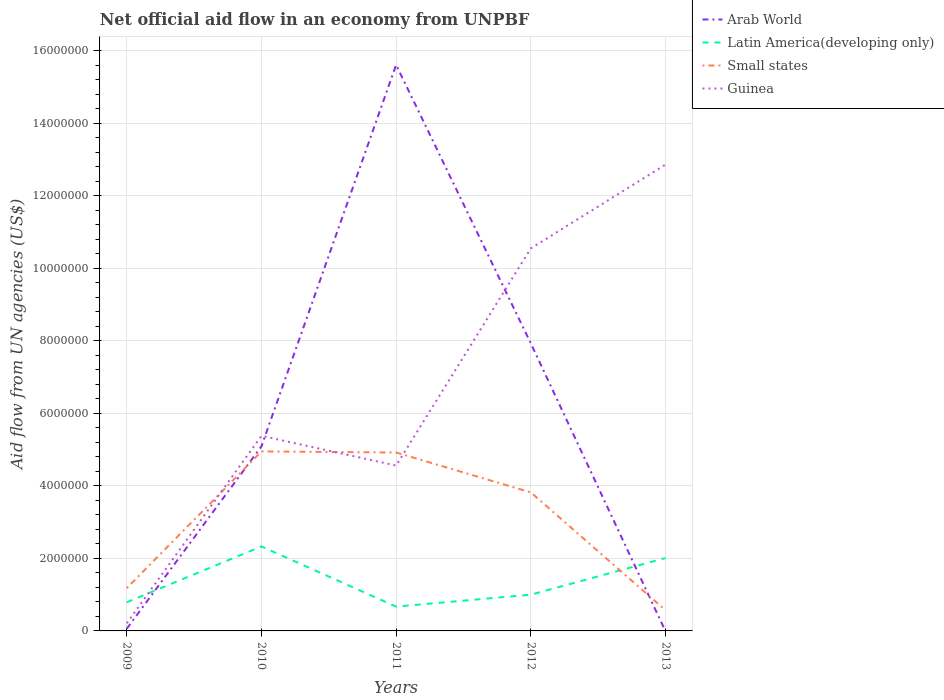Across all years, what is the maximum net official aid flow in Guinea?
Give a very brief answer. 2.10e+05. What is the total net official aid flow in Guinea in the graph?
Keep it short and to the point. -1.26e+07. What is the difference between the highest and the second highest net official aid flow in Small states?
Your answer should be very brief. 4.38e+06. How many lines are there?
Your answer should be compact. 4. How many years are there in the graph?
Your response must be concise. 5. What is the difference between two consecutive major ticks on the Y-axis?
Offer a terse response. 2.00e+06. What is the title of the graph?
Your answer should be compact. Net official aid flow in an economy from UNPBF. Does "Solomon Islands" appear as one of the legend labels in the graph?
Give a very brief answer. No. What is the label or title of the X-axis?
Your response must be concise. Years. What is the label or title of the Y-axis?
Ensure brevity in your answer.  Aid flow from UN agencies (US$). What is the Aid flow from UN agencies (US$) of Latin America(developing only) in 2009?
Your response must be concise. 7.90e+05. What is the Aid flow from UN agencies (US$) in Small states in 2009?
Offer a very short reply. 1.18e+06. What is the Aid flow from UN agencies (US$) of Arab World in 2010?
Your answer should be compact. 5.09e+06. What is the Aid flow from UN agencies (US$) in Latin America(developing only) in 2010?
Make the answer very short. 2.33e+06. What is the Aid flow from UN agencies (US$) in Small states in 2010?
Make the answer very short. 4.95e+06. What is the Aid flow from UN agencies (US$) of Guinea in 2010?
Keep it short and to the point. 5.38e+06. What is the Aid flow from UN agencies (US$) of Arab World in 2011?
Your answer should be very brief. 1.56e+07. What is the Aid flow from UN agencies (US$) of Latin America(developing only) in 2011?
Give a very brief answer. 6.70e+05. What is the Aid flow from UN agencies (US$) in Small states in 2011?
Your answer should be very brief. 4.92e+06. What is the Aid flow from UN agencies (US$) in Guinea in 2011?
Offer a very short reply. 4.56e+06. What is the Aid flow from UN agencies (US$) of Arab World in 2012?
Offer a terse response. 7.93e+06. What is the Aid flow from UN agencies (US$) in Small states in 2012?
Provide a succinct answer. 3.82e+06. What is the Aid flow from UN agencies (US$) in Guinea in 2012?
Your answer should be very brief. 1.06e+07. What is the Aid flow from UN agencies (US$) in Latin America(developing only) in 2013?
Provide a succinct answer. 2.01e+06. What is the Aid flow from UN agencies (US$) in Small states in 2013?
Offer a terse response. 5.70e+05. What is the Aid flow from UN agencies (US$) of Guinea in 2013?
Your answer should be compact. 1.29e+07. Across all years, what is the maximum Aid flow from UN agencies (US$) of Arab World?
Your answer should be very brief. 1.56e+07. Across all years, what is the maximum Aid flow from UN agencies (US$) of Latin America(developing only)?
Provide a succinct answer. 2.33e+06. Across all years, what is the maximum Aid flow from UN agencies (US$) of Small states?
Provide a succinct answer. 4.95e+06. Across all years, what is the maximum Aid flow from UN agencies (US$) of Guinea?
Your answer should be compact. 1.29e+07. Across all years, what is the minimum Aid flow from UN agencies (US$) of Arab World?
Provide a succinct answer. 0. Across all years, what is the minimum Aid flow from UN agencies (US$) of Latin America(developing only)?
Offer a terse response. 6.70e+05. Across all years, what is the minimum Aid flow from UN agencies (US$) in Small states?
Your response must be concise. 5.70e+05. What is the total Aid flow from UN agencies (US$) of Arab World in the graph?
Offer a very short reply. 2.87e+07. What is the total Aid flow from UN agencies (US$) of Latin America(developing only) in the graph?
Ensure brevity in your answer.  6.80e+06. What is the total Aid flow from UN agencies (US$) in Small states in the graph?
Your response must be concise. 1.54e+07. What is the total Aid flow from UN agencies (US$) in Guinea in the graph?
Your response must be concise. 3.36e+07. What is the difference between the Aid flow from UN agencies (US$) in Arab World in 2009 and that in 2010?
Offer a terse response. -5.03e+06. What is the difference between the Aid flow from UN agencies (US$) in Latin America(developing only) in 2009 and that in 2010?
Offer a very short reply. -1.54e+06. What is the difference between the Aid flow from UN agencies (US$) of Small states in 2009 and that in 2010?
Provide a short and direct response. -3.77e+06. What is the difference between the Aid flow from UN agencies (US$) of Guinea in 2009 and that in 2010?
Ensure brevity in your answer.  -5.17e+06. What is the difference between the Aid flow from UN agencies (US$) of Arab World in 2009 and that in 2011?
Give a very brief answer. -1.56e+07. What is the difference between the Aid flow from UN agencies (US$) in Small states in 2009 and that in 2011?
Make the answer very short. -3.74e+06. What is the difference between the Aid flow from UN agencies (US$) in Guinea in 2009 and that in 2011?
Your response must be concise. -4.35e+06. What is the difference between the Aid flow from UN agencies (US$) of Arab World in 2009 and that in 2012?
Make the answer very short. -7.87e+06. What is the difference between the Aid flow from UN agencies (US$) in Latin America(developing only) in 2009 and that in 2012?
Your response must be concise. -2.10e+05. What is the difference between the Aid flow from UN agencies (US$) of Small states in 2009 and that in 2012?
Your answer should be compact. -2.64e+06. What is the difference between the Aid flow from UN agencies (US$) in Guinea in 2009 and that in 2012?
Give a very brief answer. -1.03e+07. What is the difference between the Aid flow from UN agencies (US$) of Latin America(developing only) in 2009 and that in 2013?
Your answer should be compact. -1.22e+06. What is the difference between the Aid flow from UN agencies (US$) of Guinea in 2009 and that in 2013?
Provide a short and direct response. -1.26e+07. What is the difference between the Aid flow from UN agencies (US$) in Arab World in 2010 and that in 2011?
Provide a succinct answer. -1.05e+07. What is the difference between the Aid flow from UN agencies (US$) of Latin America(developing only) in 2010 and that in 2011?
Provide a short and direct response. 1.66e+06. What is the difference between the Aid flow from UN agencies (US$) of Small states in 2010 and that in 2011?
Offer a terse response. 3.00e+04. What is the difference between the Aid flow from UN agencies (US$) in Guinea in 2010 and that in 2011?
Your answer should be very brief. 8.20e+05. What is the difference between the Aid flow from UN agencies (US$) of Arab World in 2010 and that in 2012?
Offer a terse response. -2.84e+06. What is the difference between the Aid flow from UN agencies (US$) in Latin America(developing only) in 2010 and that in 2012?
Your answer should be compact. 1.33e+06. What is the difference between the Aid flow from UN agencies (US$) in Small states in 2010 and that in 2012?
Your answer should be very brief. 1.13e+06. What is the difference between the Aid flow from UN agencies (US$) in Guinea in 2010 and that in 2012?
Your answer should be very brief. -5.17e+06. What is the difference between the Aid flow from UN agencies (US$) in Small states in 2010 and that in 2013?
Your answer should be very brief. 4.38e+06. What is the difference between the Aid flow from UN agencies (US$) of Guinea in 2010 and that in 2013?
Provide a short and direct response. -7.48e+06. What is the difference between the Aid flow from UN agencies (US$) of Arab World in 2011 and that in 2012?
Your response must be concise. 7.68e+06. What is the difference between the Aid flow from UN agencies (US$) in Latin America(developing only) in 2011 and that in 2012?
Give a very brief answer. -3.30e+05. What is the difference between the Aid flow from UN agencies (US$) in Small states in 2011 and that in 2012?
Provide a succinct answer. 1.10e+06. What is the difference between the Aid flow from UN agencies (US$) in Guinea in 2011 and that in 2012?
Offer a terse response. -5.99e+06. What is the difference between the Aid flow from UN agencies (US$) of Latin America(developing only) in 2011 and that in 2013?
Your response must be concise. -1.34e+06. What is the difference between the Aid flow from UN agencies (US$) in Small states in 2011 and that in 2013?
Offer a very short reply. 4.35e+06. What is the difference between the Aid flow from UN agencies (US$) in Guinea in 2011 and that in 2013?
Provide a short and direct response. -8.30e+06. What is the difference between the Aid flow from UN agencies (US$) in Latin America(developing only) in 2012 and that in 2013?
Your answer should be very brief. -1.01e+06. What is the difference between the Aid flow from UN agencies (US$) in Small states in 2012 and that in 2013?
Provide a succinct answer. 3.25e+06. What is the difference between the Aid flow from UN agencies (US$) in Guinea in 2012 and that in 2013?
Your answer should be very brief. -2.31e+06. What is the difference between the Aid flow from UN agencies (US$) in Arab World in 2009 and the Aid flow from UN agencies (US$) in Latin America(developing only) in 2010?
Your response must be concise. -2.27e+06. What is the difference between the Aid flow from UN agencies (US$) in Arab World in 2009 and the Aid flow from UN agencies (US$) in Small states in 2010?
Your answer should be compact. -4.89e+06. What is the difference between the Aid flow from UN agencies (US$) in Arab World in 2009 and the Aid flow from UN agencies (US$) in Guinea in 2010?
Your answer should be compact. -5.32e+06. What is the difference between the Aid flow from UN agencies (US$) of Latin America(developing only) in 2009 and the Aid flow from UN agencies (US$) of Small states in 2010?
Your response must be concise. -4.16e+06. What is the difference between the Aid flow from UN agencies (US$) in Latin America(developing only) in 2009 and the Aid flow from UN agencies (US$) in Guinea in 2010?
Your answer should be very brief. -4.59e+06. What is the difference between the Aid flow from UN agencies (US$) in Small states in 2009 and the Aid flow from UN agencies (US$) in Guinea in 2010?
Your response must be concise. -4.20e+06. What is the difference between the Aid flow from UN agencies (US$) in Arab World in 2009 and the Aid flow from UN agencies (US$) in Latin America(developing only) in 2011?
Ensure brevity in your answer.  -6.10e+05. What is the difference between the Aid flow from UN agencies (US$) of Arab World in 2009 and the Aid flow from UN agencies (US$) of Small states in 2011?
Provide a succinct answer. -4.86e+06. What is the difference between the Aid flow from UN agencies (US$) of Arab World in 2009 and the Aid flow from UN agencies (US$) of Guinea in 2011?
Provide a short and direct response. -4.50e+06. What is the difference between the Aid flow from UN agencies (US$) of Latin America(developing only) in 2009 and the Aid flow from UN agencies (US$) of Small states in 2011?
Your answer should be compact. -4.13e+06. What is the difference between the Aid flow from UN agencies (US$) of Latin America(developing only) in 2009 and the Aid flow from UN agencies (US$) of Guinea in 2011?
Give a very brief answer. -3.77e+06. What is the difference between the Aid flow from UN agencies (US$) of Small states in 2009 and the Aid flow from UN agencies (US$) of Guinea in 2011?
Your answer should be very brief. -3.38e+06. What is the difference between the Aid flow from UN agencies (US$) of Arab World in 2009 and the Aid flow from UN agencies (US$) of Latin America(developing only) in 2012?
Your answer should be compact. -9.40e+05. What is the difference between the Aid flow from UN agencies (US$) in Arab World in 2009 and the Aid flow from UN agencies (US$) in Small states in 2012?
Provide a succinct answer. -3.76e+06. What is the difference between the Aid flow from UN agencies (US$) in Arab World in 2009 and the Aid flow from UN agencies (US$) in Guinea in 2012?
Give a very brief answer. -1.05e+07. What is the difference between the Aid flow from UN agencies (US$) of Latin America(developing only) in 2009 and the Aid flow from UN agencies (US$) of Small states in 2012?
Make the answer very short. -3.03e+06. What is the difference between the Aid flow from UN agencies (US$) of Latin America(developing only) in 2009 and the Aid flow from UN agencies (US$) of Guinea in 2012?
Make the answer very short. -9.76e+06. What is the difference between the Aid flow from UN agencies (US$) in Small states in 2009 and the Aid flow from UN agencies (US$) in Guinea in 2012?
Offer a terse response. -9.37e+06. What is the difference between the Aid flow from UN agencies (US$) in Arab World in 2009 and the Aid flow from UN agencies (US$) in Latin America(developing only) in 2013?
Provide a short and direct response. -1.95e+06. What is the difference between the Aid flow from UN agencies (US$) in Arab World in 2009 and the Aid flow from UN agencies (US$) in Small states in 2013?
Provide a short and direct response. -5.10e+05. What is the difference between the Aid flow from UN agencies (US$) in Arab World in 2009 and the Aid flow from UN agencies (US$) in Guinea in 2013?
Keep it short and to the point. -1.28e+07. What is the difference between the Aid flow from UN agencies (US$) of Latin America(developing only) in 2009 and the Aid flow from UN agencies (US$) of Guinea in 2013?
Provide a succinct answer. -1.21e+07. What is the difference between the Aid flow from UN agencies (US$) of Small states in 2009 and the Aid flow from UN agencies (US$) of Guinea in 2013?
Give a very brief answer. -1.17e+07. What is the difference between the Aid flow from UN agencies (US$) in Arab World in 2010 and the Aid flow from UN agencies (US$) in Latin America(developing only) in 2011?
Make the answer very short. 4.42e+06. What is the difference between the Aid flow from UN agencies (US$) of Arab World in 2010 and the Aid flow from UN agencies (US$) of Guinea in 2011?
Ensure brevity in your answer.  5.30e+05. What is the difference between the Aid flow from UN agencies (US$) in Latin America(developing only) in 2010 and the Aid flow from UN agencies (US$) in Small states in 2011?
Provide a succinct answer. -2.59e+06. What is the difference between the Aid flow from UN agencies (US$) of Latin America(developing only) in 2010 and the Aid flow from UN agencies (US$) of Guinea in 2011?
Provide a short and direct response. -2.23e+06. What is the difference between the Aid flow from UN agencies (US$) in Small states in 2010 and the Aid flow from UN agencies (US$) in Guinea in 2011?
Offer a terse response. 3.90e+05. What is the difference between the Aid flow from UN agencies (US$) of Arab World in 2010 and the Aid flow from UN agencies (US$) of Latin America(developing only) in 2012?
Give a very brief answer. 4.09e+06. What is the difference between the Aid flow from UN agencies (US$) in Arab World in 2010 and the Aid flow from UN agencies (US$) in Small states in 2012?
Your answer should be very brief. 1.27e+06. What is the difference between the Aid flow from UN agencies (US$) of Arab World in 2010 and the Aid flow from UN agencies (US$) of Guinea in 2012?
Provide a short and direct response. -5.46e+06. What is the difference between the Aid flow from UN agencies (US$) of Latin America(developing only) in 2010 and the Aid flow from UN agencies (US$) of Small states in 2012?
Give a very brief answer. -1.49e+06. What is the difference between the Aid flow from UN agencies (US$) of Latin America(developing only) in 2010 and the Aid flow from UN agencies (US$) of Guinea in 2012?
Offer a very short reply. -8.22e+06. What is the difference between the Aid flow from UN agencies (US$) of Small states in 2010 and the Aid flow from UN agencies (US$) of Guinea in 2012?
Your response must be concise. -5.60e+06. What is the difference between the Aid flow from UN agencies (US$) of Arab World in 2010 and the Aid flow from UN agencies (US$) of Latin America(developing only) in 2013?
Offer a terse response. 3.08e+06. What is the difference between the Aid flow from UN agencies (US$) of Arab World in 2010 and the Aid flow from UN agencies (US$) of Small states in 2013?
Give a very brief answer. 4.52e+06. What is the difference between the Aid flow from UN agencies (US$) in Arab World in 2010 and the Aid flow from UN agencies (US$) in Guinea in 2013?
Provide a short and direct response. -7.77e+06. What is the difference between the Aid flow from UN agencies (US$) in Latin America(developing only) in 2010 and the Aid flow from UN agencies (US$) in Small states in 2013?
Give a very brief answer. 1.76e+06. What is the difference between the Aid flow from UN agencies (US$) in Latin America(developing only) in 2010 and the Aid flow from UN agencies (US$) in Guinea in 2013?
Ensure brevity in your answer.  -1.05e+07. What is the difference between the Aid flow from UN agencies (US$) in Small states in 2010 and the Aid flow from UN agencies (US$) in Guinea in 2013?
Your response must be concise. -7.91e+06. What is the difference between the Aid flow from UN agencies (US$) in Arab World in 2011 and the Aid flow from UN agencies (US$) in Latin America(developing only) in 2012?
Your answer should be very brief. 1.46e+07. What is the difference between the Aid flow from UN agencies (US$) in Arab World in 2011 and the Aid flow from UN agencies (US$) in Small states in 2012?
Offer a terse response. 1.18e+07. What is the difference between the Aid flow from UN agencies (US$) in Arab World in 2011 and the Aid flow from UN agencies (US$) in Guinea in 2012?
Your response must be concise. 5.06e+06. What is the difference between the Aid flow from UN agencies (US$) of Latin America(developing only) in 2011 and the Aid flow from UN agencies (US$) of Small states in 2012?
Provide a succinct answer. -3.15e+06. What is the difference between the Aid flow from UN agencies (US$) of Latin America(developing only) in 2011 and the Aid flow from UN agencies (US$) of Guinea in 2012?
Your answer should be very brief. -9.88e+06. What is the difference between the Aid flow from UN agencies (US$) of Small states in 2011 and the Aid flow from UN agencies (US$) of Guinea in 2012?
Offer a very short reply. -5.63e+06. What is the difference between the Aid flow from UN agencies (US$) in Arab World in 2011 and the Aid flow from UN agencies (US$) in Latin America(developing only) in 2013?
Give a very brief answer. 1.36e+07. What is the difference between the Aid flow from UN agencies (US$) in Arab World in 2011 and the Aid flow from UN agencies (US$) in Small states in 2013?
Your answer should be very brief. 1.50e+07. What is the difference between the Aid flow from UN agencies (US$) in Arab World in 2011 and the Aid flow from UN agencies (US$) in Guinea in 2013?
Your response must be concise. 2.75e+06. What is the difference between the Aid flow from UN agencies (US$) in Latin America(developing only) in 2011 and the Aid flow from UN agencies (US$) in Small states in 2013?
Give a very brief answer. 1.00e+05. What is the difference between the Aid flow from UN agencies (US$) in Latin America(developing only) in 2011 and the Aid flow from UN agencies (US$) in Guinea in 2013?
Give a very brief answer. -1.22e+07. What is the difference between the Aid flow from UN agencies (US$) in Small states in 2011 and the Aid flow from UN agencies (US$) in Guinea in 2013?
Your answer should be compact. -7.94e+06. What is the difference between the Aid flow from UN agencies (US$) in Arab World in 2012 and the Aid flow from UN agencies (US$) in Latin America(developing only) in 2013?
Offer a very short reply. 5.92e+06. What is the difference between the Aid flow from UN agencies (US$) in Arab World in 2012 and the Aid flow from UN agencies (US$) in Small states in 2013?
Your response must be concise. 7.36e+06. What is the difference between the Aid flow from UN agencies (US$) in Arab World in 2012 and the Aid flow from UN agencies (US$) in Guinea in 2013?
Your response must be concise. -4.93e+06. What is the difference between the Aid flow from UN agencies (US$) of Latin America(developing only) in 2012 and the Aid flow from UN agencies (US$) of Small states in 2013?
Provide a short and direct response. 4.30e+05. What is the difference between the Aid flow from UN agencies (US$) in Latin America(developing only) in 2012 and the Aid flow from UN agencies (US$) in Guinea in 2013?
Provide a succinct answer. -1.19e+07. What is the difference between the Aid flow from UN agencies (US$) of Small states in 2012 and the Aid flow from UN agencies (US$) of Guinea in 2013?
Make the answer very short. -9.04e+06. What is the average Aid flow from UN agencies (US$) in Arab World per year?
Your answer should be compact. 5.74e+06. What is the average Aid flow from UN agencies (US$) in Latin America(developing only) per year?
Your response must be concise. 1.36e+06. What is the average Aid flow from UN agencies (US$) in Small states per year?
Provide a short and direct response. 3.09e+06. What is the average Aid flow from UN agencies (US$) of Guinea per year?
Your answer should be very brief. 6.71e+06. In the year 2009, what is the difference between the Aid flow from UN agencies (US$) of Arab World and Aid flow from UN agencies (US$) of Latin America(developing only)?
Give a very brief answer. -7.30e+05. In the year 2009, what is the difference between the Aid flow from UN agencies (US$) of Arab World and Aid flow from UN agencies (US$) of Small states?
Keep it short and to the point. -1.12e+06. In the year 2009, what is the difference between the Aid flow from UN agencies (US$) of Latin America(developing only) and Aid flow from UN agencies (US$) of Small states?
Offer a very short reply. -3.90e+05. In the year 2009, what is the difference between the Aid flow from UN agencies (US$) of Latin America(developing only) and Aid flow from UN agencies (US$) of Guinea?
Provide a short and direct response. 5.80e+05. In the year 2009, what is the difference between the Aid flow from UN agencies (US$) of Small states and Aid flow from UN agencies (US$) of Guinea?
Ensure brevity in your answer.  9.70e+05. In the year 2010, what is the difference between the Aid flow from UN agencies (US$) in Arab World and Aid flow from UN agencies (US$) in Latin America(developing only)?
Provide a succinct answer. 2.76e+06. In the year 2010, what is the difference between the Aid flow from UN agencies (US$) of Arab World and Aid flow from UN agencies (US$) of Guinea?
Your response must be concise. -2.90e+05. In the year 2010, what is the difference between the Aid flow from UN agencies (US$) in Latin America(developing only) and Aid flow from UN agencies (US$) in Small states?
Provide a short and direct response. -2.62e+06. In the year 2010, what is the difference between the Aid flow from UN agencies (US$) of Latin America(developing only) and Aid flow from UN agencies (US$) of Guinea?
Your answer should be very brief. -3.05e+06. In the year 2010, what is the difference between the Aid flow from UN agencies (US$) of Small states and Aid flow from UN agencies (US$) of Guinea?
Your answer should be compact. -4.30e+05. In the year 2011, what is the difference between the Aid flow from UN agencies (US$) of Arab World and Aid flow from UN agencies (US$) of Latin America(developing only)?
Provide a short and direct response. 1.49e+07. In the year 2011, what is the difference between the Aid flow from UN agencies (US$) of Arab World and Aid flow from UN agencies (US$) of Small states?
Your answer should be compact. 1.07e+07. In the year 2011, what is the difference between the Aid flow from UN agencies (US$) in Arab World and Aid flow from UN agencies (US$) in Guinea?
Ensure brevity in your answer.  1.10e+07. In the year 2011, what is the difference between the Aid flow from UN agencies (US$) in Latin America(developing only) and Aid flow from UN agencies (US$) in Small states?
Provide a short and direct response. -4.25e+06. In the year 2011, what is the difference between the Aid flow from UN agencies (US$) in Latin America(developing only) and Aid flow from UN agencies (US$) in Guinea?
Provide a succinct answer. -3.89e+06. In the year 2011, what is the difference between the Aid flow from UN agencies (US$) of Small states and Aid flow from UN agencies (US$) of Guinea?
Provide a succinct answer. 3.60e+05. In the year 2012, what is the difference between the Aid flow from UN agencies (US$) of Arab World and Aid flow from UN agencies (US$) of Latin America(developing only)?
Keep it short and to the point. 6.93e+06. In the year 2012, what is the difference between the Aid flow from UN agencies (US$) in Arab World and Aid flow from UN agencies (US$) in Small states?
Your response must be concise. 4.11e+06. In the year 2012, what is the difference between the Aid flow from UN agencies (US$) of Arab World and Aid flow from UN agencies (US$) of Guinea?
Make the answer very short. -2.62e+06. In the year 2012, what is the difference between the Aid flow from UN agencies (US$) of Latin America(developing only) and Aid flow from UN agencies (US$) of Small states?
Your answer should be compact. -2.82e+06. In the year 2012, what is the difference between the Aid flow from UN agencies (US$) of Latin America(developing only) and Aid flow from UN agencies (US$) of Guinea?
Keep it short and to the point. -9.55e+06. In the year 2012, what is the difference between the Aid flow from UN agencies (US$) of Small states and Aid flow from UN agencies (US$) of Guinea?
Give a very brief answer. -6.73e+06. In the year 2013, what is the difference between the Aid flow from UN agencies (US$) in Latin America(developing only) and Aid flow from UN agencies (US$) in Small states?
Your response must be concise. 1.44e+06. In the year 2013, what is the difference between the Aid flow from UN agencies (US$) of Latin America(developing only) and Aid flow from UN agencies (US$) of Guinea?
Offer a very short reply. -1.08e+07. In the year 2013, what is the difference between the Aid flow from UN agencies (US$) of Small states and Aid flow from UN agencies (US$) of Guinea?
Keep it short and to the point. -1.23e+07. What is the ratio of the Aid flow from UN agencies (US$) in Arab World in 2009 to that in 2010?
Your response must be concise. 0.01. What is the ratio of the Aid flow from UN agencies (US$) of Latin America(developing only) in 2009 to that in 2010?
Offer a terse response. 0.34. What is the ratio of the Aid flow from UN agencies (US$) of Small states in 2009 to that in 2010?
Offer a terse response. 0.24. What is the ratio of the Aid flow from UN agencies (US$) of Guinea in 2009 to that in 2010?
Keep it short and to the point. 0.04. What is the ratio of the Aid flow from UN agencies (US$) in Arab World in 2009 to that in 2011?
Offer a terse response. 0. What is the ratio of the Aid flow from UN agencies (US$) in Latin America(developing only) in 2009 to that in 2011?
Your response must be concise. 1.18. What is the ratio of the Aid flow from UN agencies (US$) in Small states in 2009 to that in 2011?
Provide a succinct answer. 0.24. What is the ratio of the Aid flow from UN agencies (US$) in Guinea in 2009 to that in 2011?
Make the answer very short. 0.05. What is the ratio of the Aid flow from UN agencies (US$) of Arab World in 2009 to that in 2012?
Provide a succinct answer. 0.01. What is the ratio of the Aid flow from UN agencies (US$) in Latin America(developing only) in 2009 to that in 2012?
Give a very brief answer. 0.79. What is the ratio of the Aid flow from UN agencies (US$) of Small states in 2009 to that in 2012?
Ensure brevity in your answer.  0.31. What is the ratio of the Aid flow from UN agencies (US$) of Guinea in 2009 to that in 2012?
Make the answer very short. 0.02. What is the ratio of the Aid flow from UN agencies (US$) of Latin America(developing only) in 2009 to that in 2013?
Offer a very short reply. 0.39. What is the ratio of the Aid flow from UN agencies (US$) in Small states in 2009 to that in 2013?
Keep it short and to the point. 2.07. What is the ratio of the Aid flow from UN agencies (US$) of Guinea in 2009 to that in 2013?
Offer a very short reply. 0.02. What is the ratio of the Aid flow from UN agencies (US$) of Arab World in 2010 to that in 2011?
Make the answer very short. 0.33. What is the ratio of the Aid flow from UN agencies (US$) in Latin America(developing only) in 2010 to that in 2011?
Make the answer very short. 3.48. What is the ratio of the Aid flow from UN agencies (US$) of Small states in 2010 to that in 2011?
Provide a succinct answer. 1.01. What is the ratio of the Aid flow from UN agencies (US$) in Guinea in 2010 to that in 2011?
Your answer should be very brief. 1.18. What is the ratio of the Aid flow from UN agencies (US$) in Arab World in 2010 to that in 2012?
Offer a terse response. 0.64. What is the ratio of the Aid flow from UN agencies (US$) of Latin America(developing only) in 2010 to that in 2012?
Offer a very short reply. 2.33. What is the ratio of the Aid flow from UN agencies (US$) of Small states in 2010 to that in 2012?
Offer a terse response. 1.3. What is the ratio of the Aid flow from UN agencies (US$) in Guinea in 2010 to that in 2012?
Your answer should be very brief. 0.51. What is the ratio of the Aid flow from UN agencies (US$) in Latin America(developing only) in 2010 to that in 2013?
Give a very brief answer. 1.16. What is the ratio of the Aid flow from UN agencies (US$) of Small states in 2010 to that in 2013?
Make the answer very short. 8.68. What is the ratio of the Aid flow from UN agencies (US$) of Guinea in 2010 to that in 2013?
Offer a terse response. 0.42. What is the ratio of the Aid flow from UN agencies (US$) of Arab World in 2011 to that in 2012?
Offer a terse response. 1.97. What is the ratio of the Aid flow from UN agencies (US$) of Latin America(developing only) in 2011 to that in 2012?
Your response must be concise. 0.67. What is the ratio of the Aid flow from UN agencies (US$) of Small states in 2011 to that in 2012?
Give a very brief answer. 1.29. What is the ratio of the Aid flow from UN agencies (US$) of Guinea in 2011 to that in 2012?
Your answer should be compact. 0.43. What is the ratio of the Aid flow from UN agencies (US$) in Latin America(developing only) in 2011 to that in 2013?
Keep it short and to the point. 0.33. What is the ratio of the Aid flow from UN agencies (US$) of Small states in 2011 to that in 2013?
Offer a very short reply. 8.63. What is the ratio of the Aid flow from UN agencies (US$) of Guinea in 2011 to that in 2013?
Offer a very short reply. 0.35. What is the ratio of the Aid flow from UN agencies (US$) of Latin America(developing only) in 2012 to that in 2013?
Ensure brevity in your answer.  0.5. What is the ratio of the Aid flow from UN agencies (US$) in Small states in 2012 to that in 2013?
Your answer should be very brief. 6.7. What is the ratio of the Aid flow from UN agencies (US$) in Guinea in 2012 to that in 2013?
Your answer should be very brief. 0.82. What is the difference between the highest and the second highest Aid flow from UN agencies (US$) of Arab World?
Your response must be concise. 7.68e+06. What is the difference between the highest and the second highest Aid flow from UN agencies (US$) of Small states?
Provide a succinct answer. 3.00e+04. What is the difference between the highest and the second highest Aid flow from UN agencies (US$) of Guinea?
Keep it short and to the point. 2.31e+06. What is the difference between the highest and the lowest Aid flow from UN agencies (US$) of Arab World?
Your response must be concise. 1.56e+07. What is the difference between the highest and the lowest Aid flow from UN agencies (US$) of Latin America(developing only)?
Make the answer very short. 1.66e+06. What is the difference between the highest and the lowest Aid flow from UN agencies (US$) in Small states?
Provide a succinct answer. 4.38e+06. What is the difference between the highest and the lowest Aid flow from UN agencies (US$) of Guinea?
Your answer should be compact. 1.26e+07. 